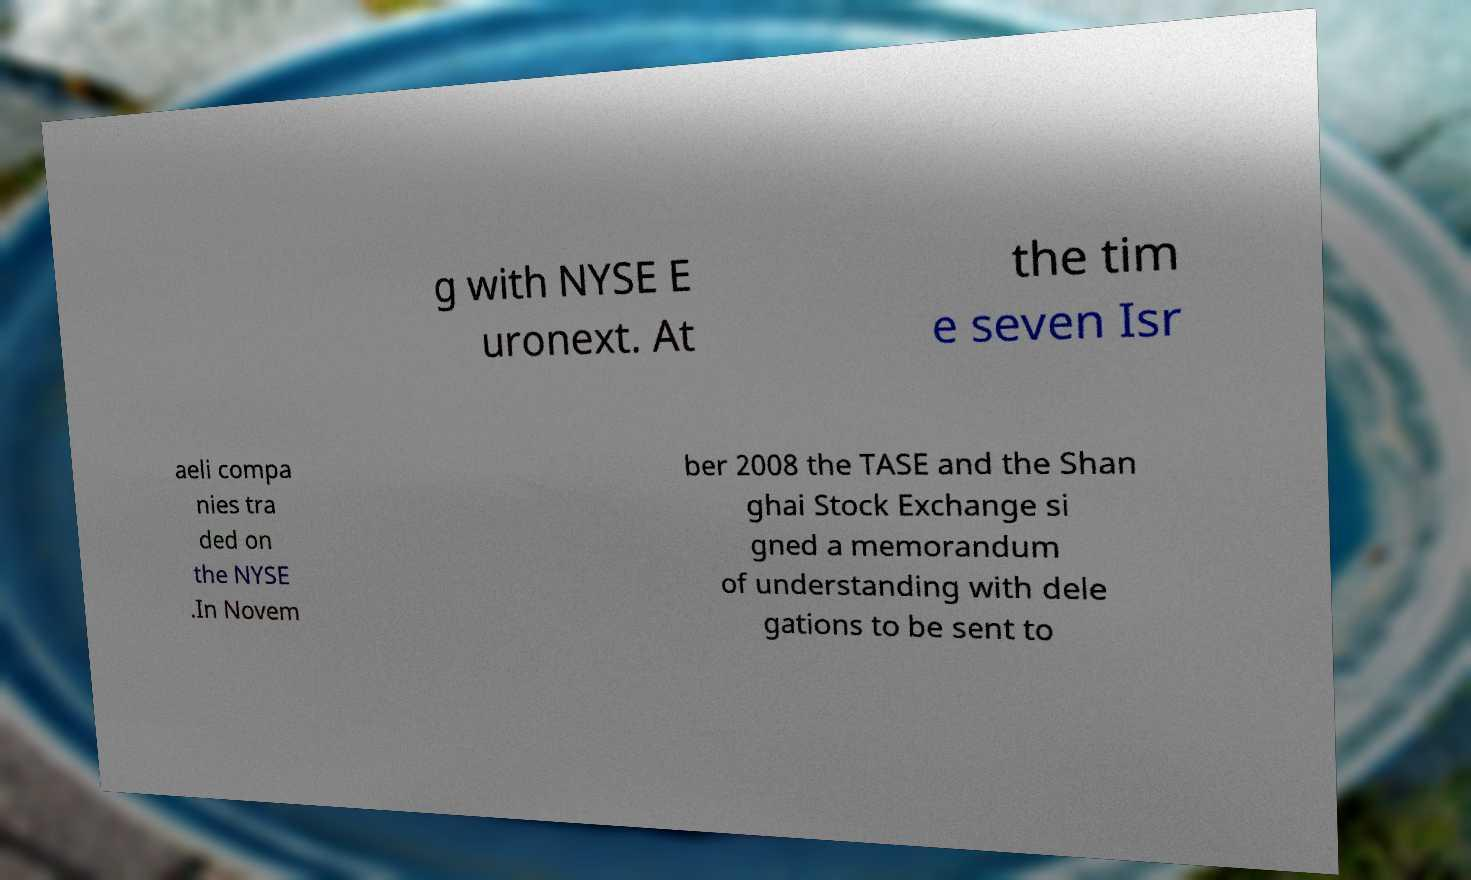I need the written content from this picture converted into text. Can you do that? g with NYSE E uronext. At the tim e seven Isr aeli compa nies tra ded on the NYSE .In Novem ber 2008 the TASE and the Shan ghai Stock Exchange si gned a memorandum of understanding with dele gations to be sent to 